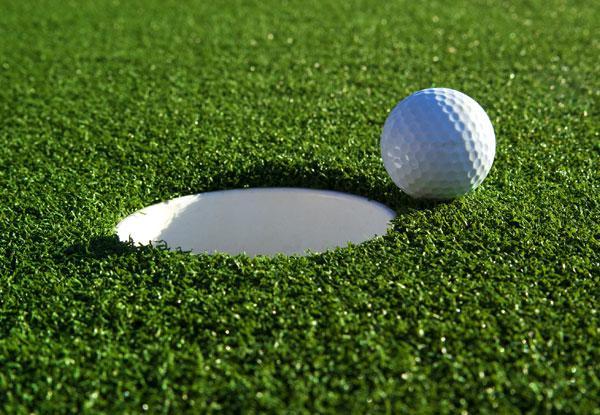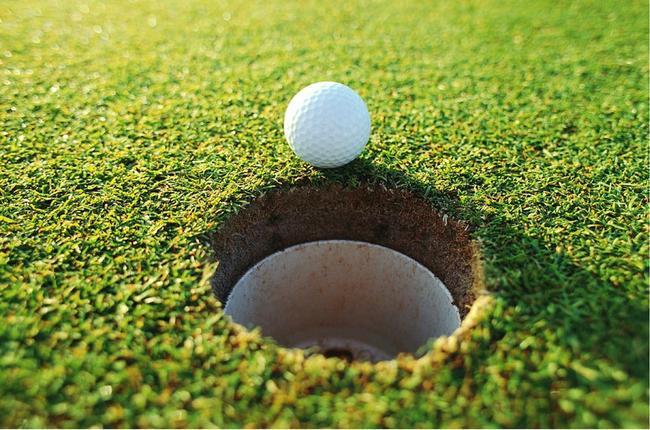The first image is the image on the left, the second image is the image on the right. For the images shown, is this caption "The ball is near the hole." true? Answer yes or no. Yes. The first image is the image on the left, the second image is the image on the right. Evaluate the accuracy of this statement regarding the images: "An image shows a golf club behind a ball that is not on a tee.". Is it true? Answer yes or no. No. 